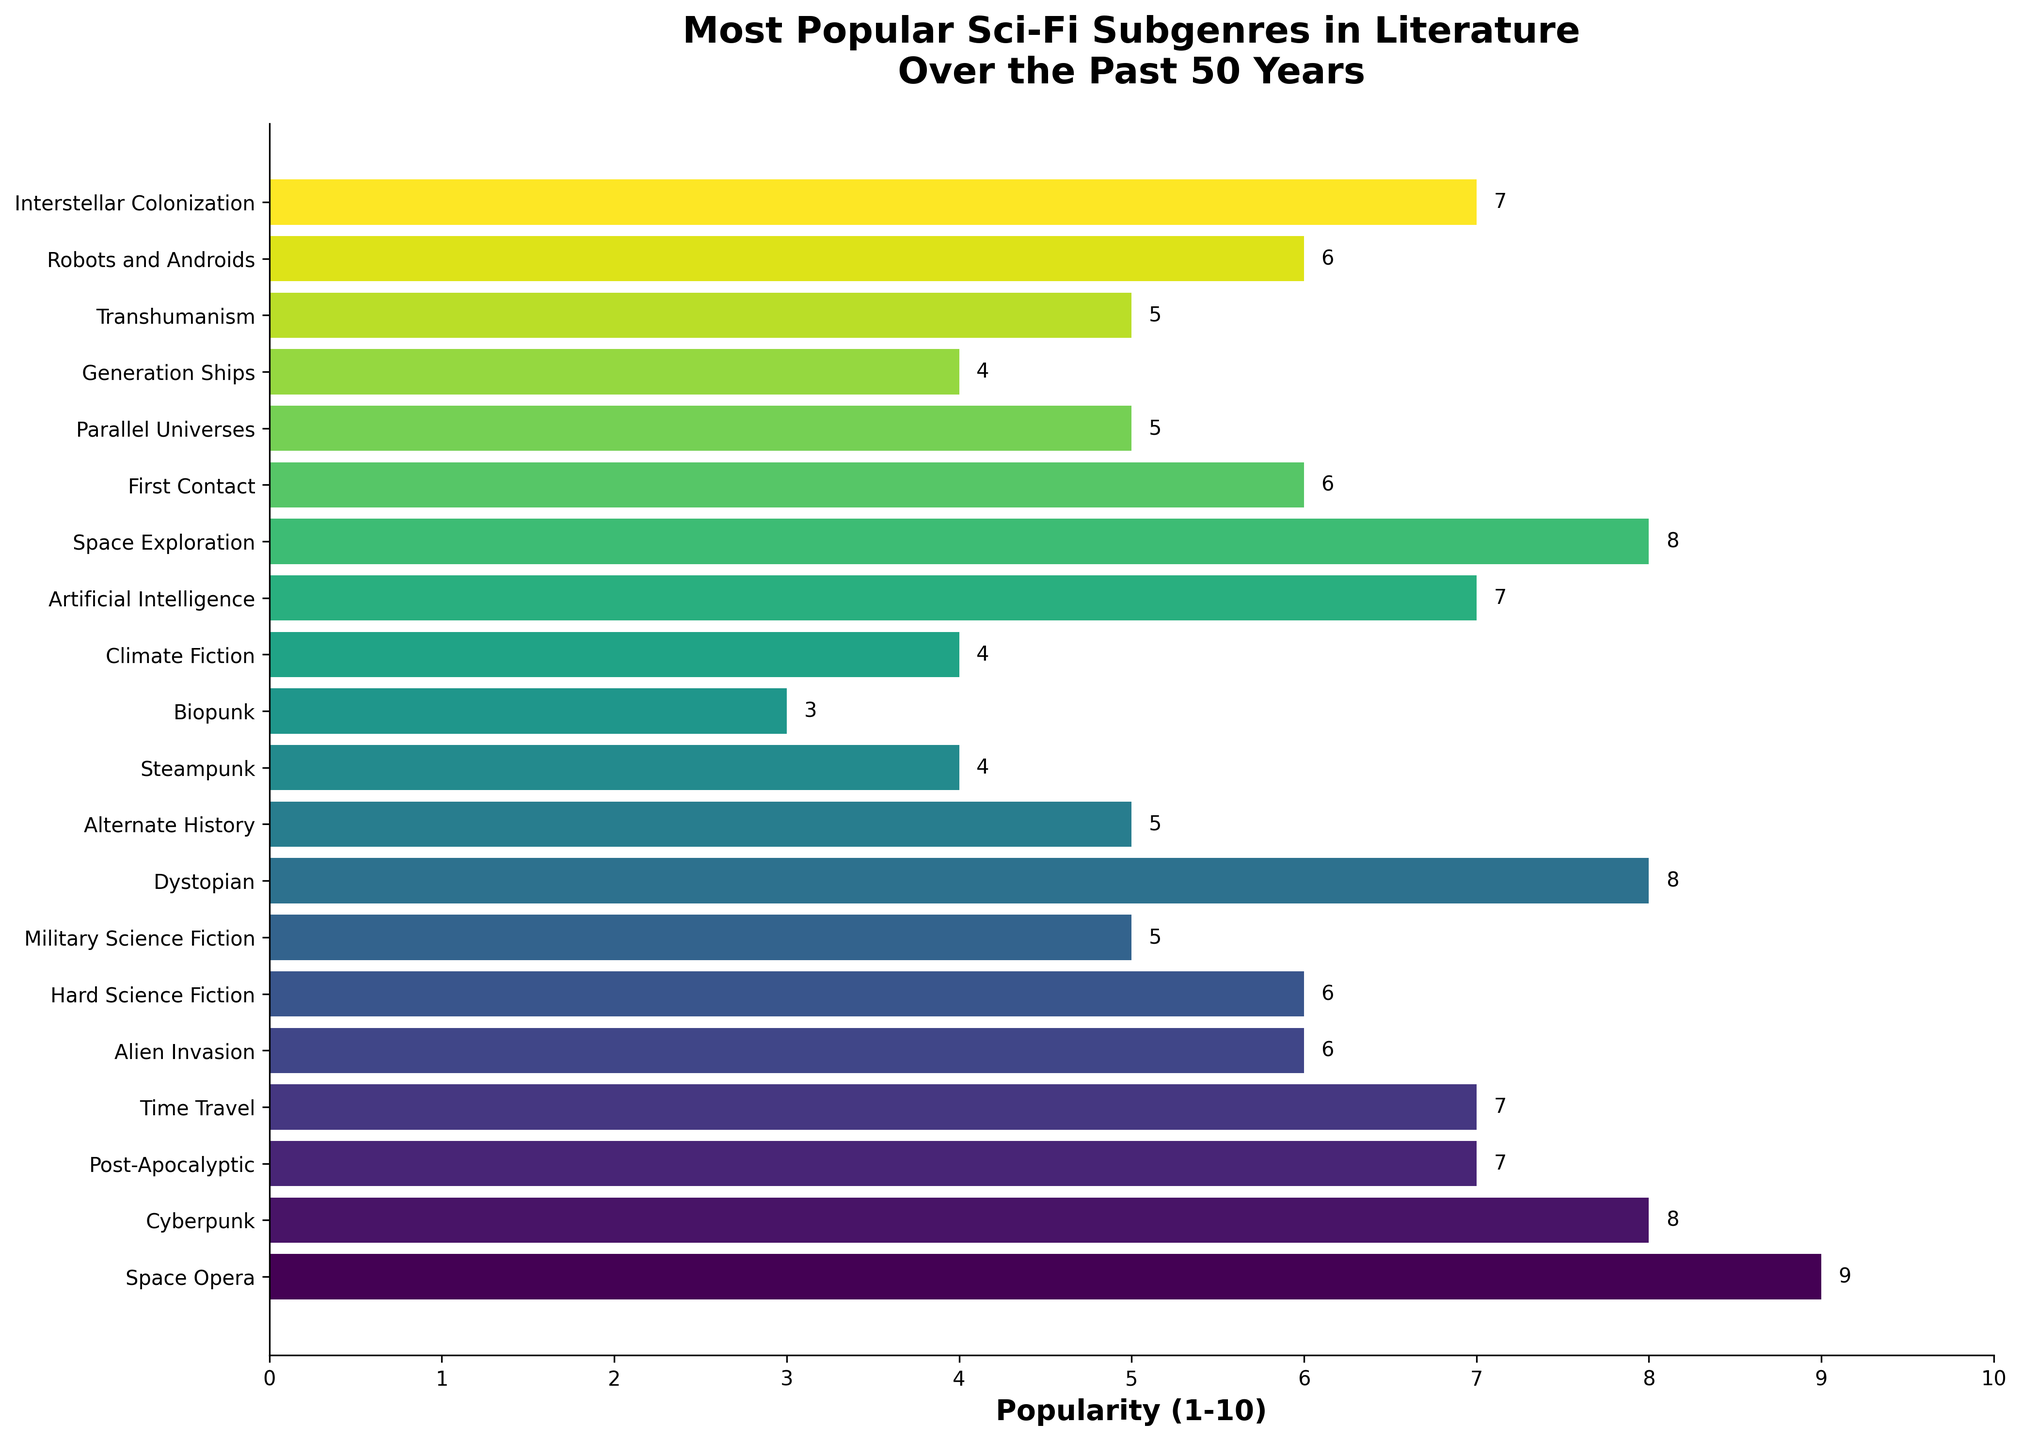Which sci-fi subgenre has the highest popularity rating? Identify the bar with the highest numerical value along the x-axis. The Space Opera subgenre reaches a maximum popularity of 9.
Answer: Space Opera How many subgenres have a popularity rating of 6? Count the bars that reach the 6 mark on the x-axis. The subgenres with ratings of 6 are Alien Invasion, Hard Science Fiction, First Contact, and Robots and Androids.
Answer: 4 Which subgenre has a lower popularity rating: Hard Science Fiction or Steampunk? Compare the lengths of the bars for Hard Science Fiction and Steampunk. Hard Science Fiction has a rating of 6, while Steampunk has a rating of 4.
Answer: Steampunk What’s the difference in popularity between Cyberpunk and Military Science Fiction? Subtract the popularity rating of Military Science Fiction (5) from Cyberpunk (8). 8 - 5 = 3.
Answer: 3 What are the top three most popular sci-fi subgenres? Identify the three bars with the highest values: Space Opera (9), Cyberpunk (8), and a tie between Dystopian and Space Exploration at 8.
Answer: Space Opera, Cyberpunk, Dystopian, Space Exploration What is the average popularity rating of the subgenres with a rating of 5? Add the popularity ratings and divide by the number of subgenres: (Military Science Fiction + Alternate History + Parallel Universes + Transhumanism) / 4 = (5 + 5 + 5 + 5) / 4 = 5.
Answer: 5 Which subgenre has the same popularity rating as Post-Apocalyptic? Find the bar that aligns with the value for Post-Apocalyptic (7). Subgenres matching this rating are Time Travel, Artificial Intelligence, and Interstellar Colonization.
Answer: Time Travel, Artificial Intelligence, Interstellar Colonization How many subgenres have a popularity rating greater than 7? Count bars with ratings higher than 7: Space Opera, Cyberpunk, Dystopian, and Space Exploration.
Answer: 4 What is the combined popularity rating of Climate Fiction and Steampunk? Add the popularity ratings for Climate Fiction (4) and Steampunk (4): 4 + 4 = 8.
Answer: 8 Which subgenres have a higher popularity rating: Biopunk or Generation Ships? Compare the lengths of the bars for Biopunk (3) and Generation Ships (4).
Answer: Generation Ships 